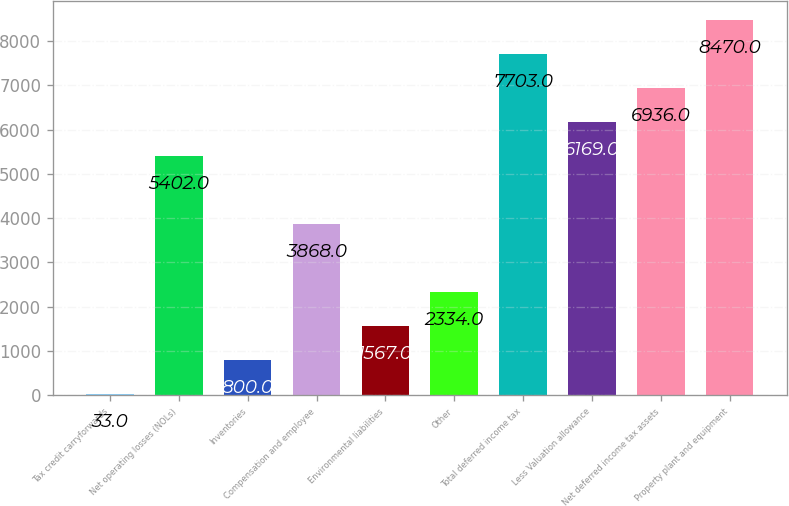Convert chart to OTSL. <chart><loc_0><loc_0><loc_500><loc_500><bar_chart><fcel>Tax credit carryforwards<fcel>Net operating losses (NOLs)<fcel>Inventories<fcel>Compensation and employee<fcel>Environmental liabilities<fcel>Other<fcel>Total deferred income tax<fcel>Less Valuation allowance<fcel>Net deferred income tax assets<fcel>Property plant and equipment<nl><fcel>33<fcel>5402<fcel>800<fcel>3868<fcel>1567<fcel>2334<fcel>7703<fcel>6169<fcel>6936<fcel>8470<nl></chart> 